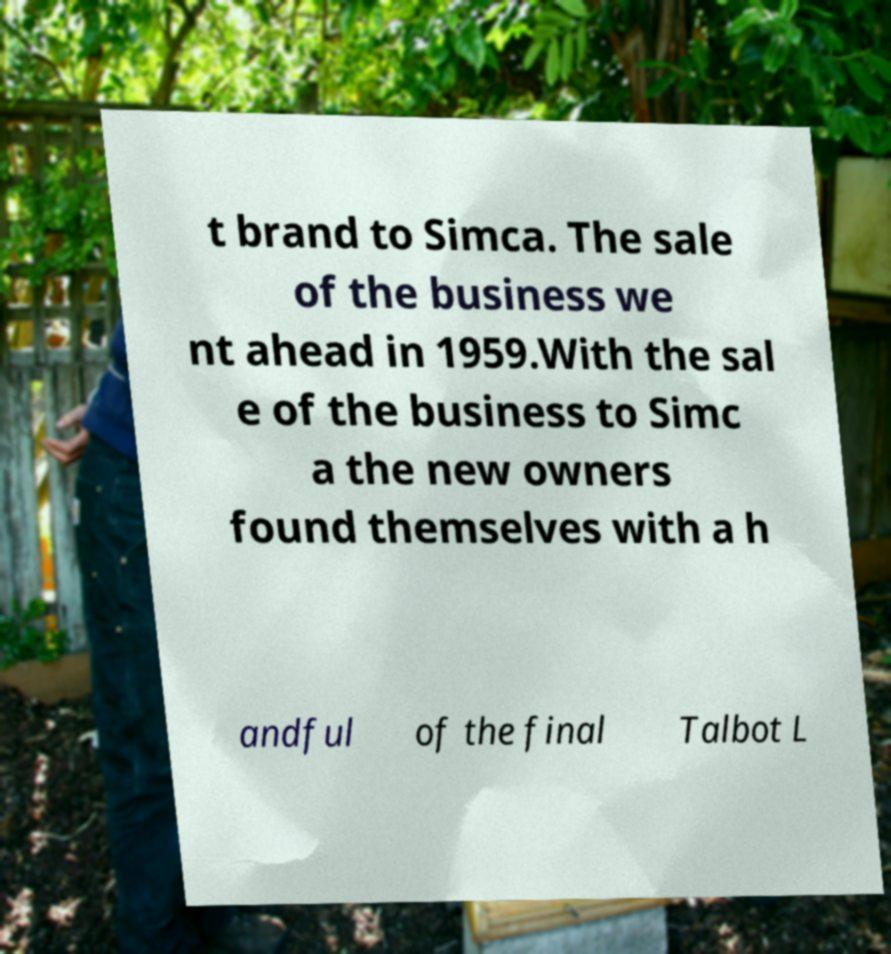Can you accurately transcribe the text from the provided image for me? t brand to Simca. The sale of the business we nt ahead in 1959.With the sal e of the business to Simc a the new owners found themselves with a h andful of the final Talbot L 